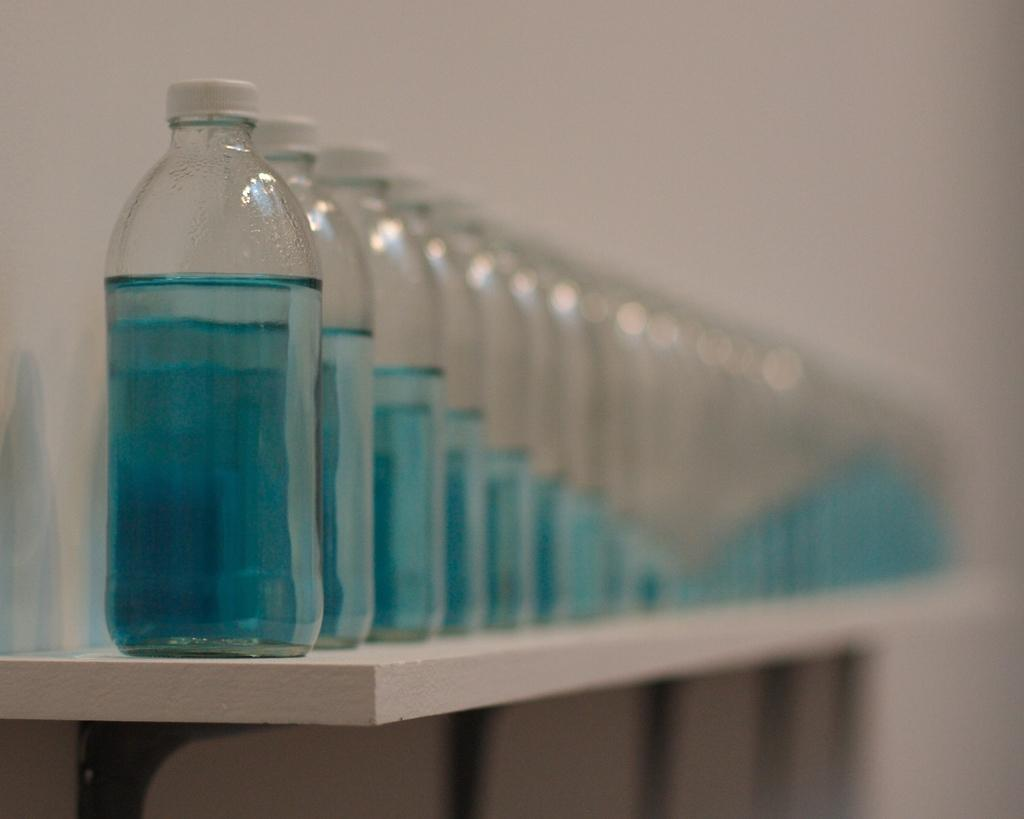What is the main subject of the image? The main subject of the image is a group of bottles. Can you describe the bottles in the image? Unfortunately, the facts provided do not give any details about the bottles, so we cannot describe them further. What is visible in the background of the image? There is a wall in the background of the image. What type of cushion is being used to serve the eggnog in the image? There is no eggnog or cushion present in the image, so this question cannot be answered. 